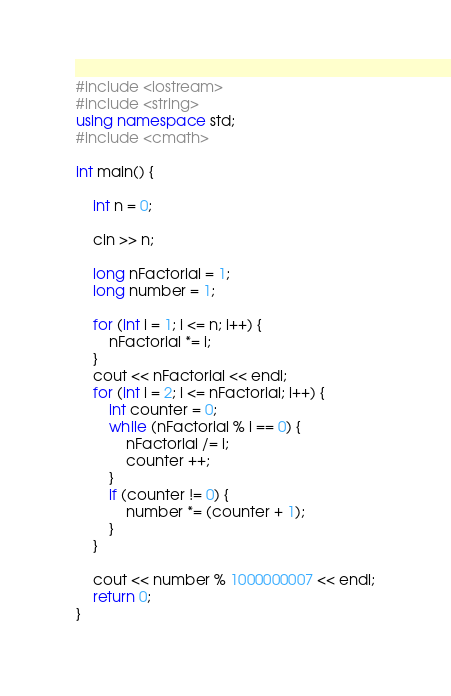<code> <loc_0><loc_0><loc_500><loc_500><_C++_>#include <iostream>
#include <string>
using namespace std;
#include <cmath>

int main() {

    int n = 0;
    
    cin >> n;
    
    long nFactorial = 1;
    long number = 1;
    
    for (int i = 1; i <= n; i++) {
        nFactorial *= i;
    }
    cout << nFactorial << endl;
    for (int i = 2; i <= nFactorial; i++) {
        int counter = 0;
        while (nFactorial % i == 0) {
            nFactorial /= i;
            counter ++;
        }
        if (counter != 0) {
            number *= (counter + 1);
        }
    }
    
    cout << number % 1000000007 << endl;
    return 0;
}

</code> 